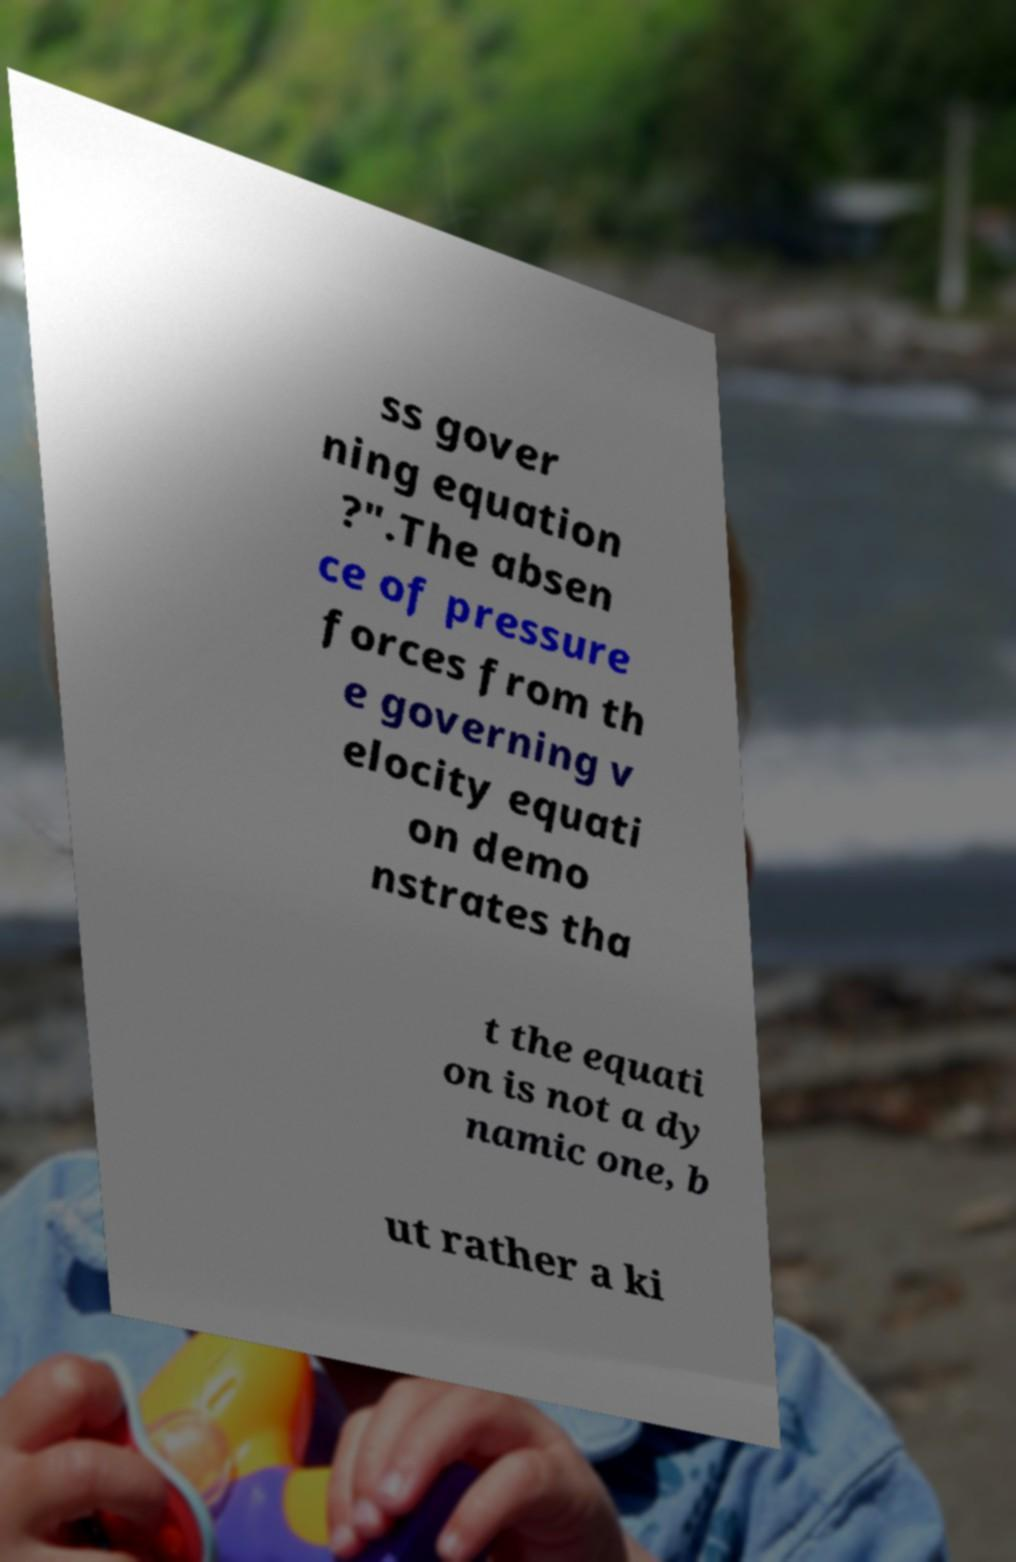For documentation purposes, I need the text within this image transcribed. Could you provide that? ss gover ning equation ?".The absen ce of pressure forces from th e governing v elocity equati on demo nstrates tha t the equati on is not a dy namic one, b ut rather a ki 